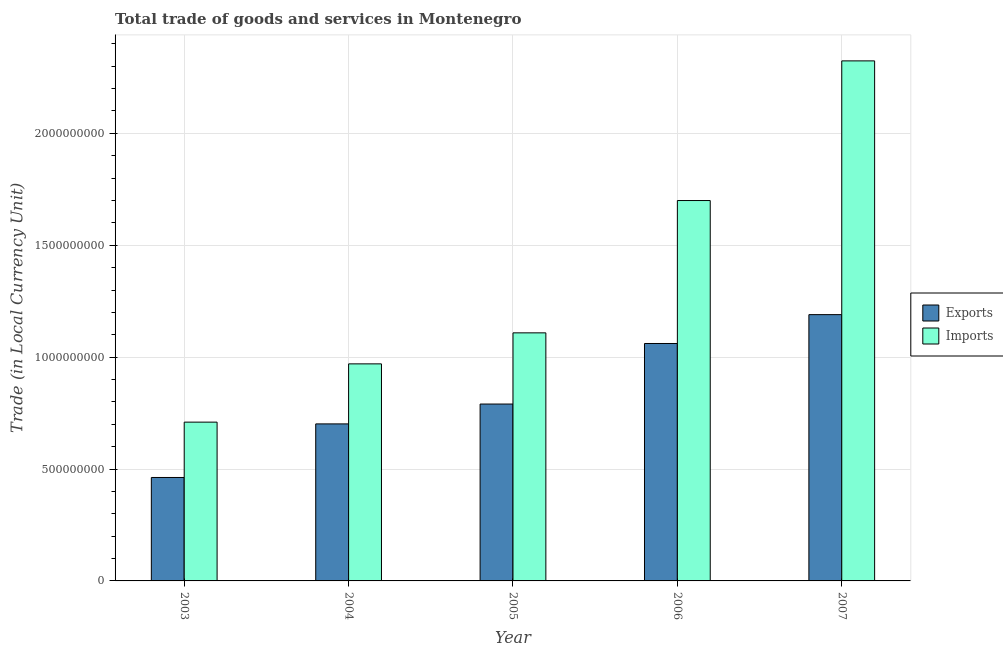Are the number of bars per tick equal to the number of legend labels?
Offer a terse response. Yes. Are the number of bars on each tick of the X-axis equal?
Give a very brief answer. Yes. How many bars are there on the 2nd tick from the left?
Your response must be concise. 2. How many bars are there on the 1st tick from the right?
Ensure brevity in your answer.  2. In how many cases, is the number of bars for a given year not equal to the number of legend labels?
Make the answer very short. 0. What is the imports of goods and services in 2005?
Give a very brief answer. 1.11e+09. Across all years, what is the maximum export of goods and services?
Your answer should be very brief. 1.19e+09. Across all years, what is the minimum imports of goods and services?
Your response must be concise. 7.10e+08. In which year was the imports of goods and services maximum?
Offer a very short reply. 2007. What is the total imports of goods and services in the graph?
Your answer should be very brief. 6.81e+09. What is the difference between the imports of goods and services in 2004 and that in 2006?
Make the answer very short. -7.30e+08. What is the difference between the export of goods and services in 2006 and the imports of goods and services in 2003?
Offer a terse response. 5.99e+08. What is the average imports of goods and services per year?
Offer a terse response. 1.36e+09. In the year 2003, what is the difference between the export of goods and services and imports of goods and services?
Ensure brevity in your answer.  0. What is the ratio of the export of goods and services in 2003 to that in 2004?
Offer a terse response. 0.66. Is the difference between the imports of goods and services in 2003 and 2007 greater than the difference between the export of goods and services in 2003 and 2007?
Your response must be concise. No. What is the difference between the highest and the second highest export of goods and services?
Give a very brief answer. 1.29e+08. What is the difference between the highest and the lowest imports of goods and services?
Keep it short and to the point. 1.61e+09. In how many years, is the imports of goods and services greater than the average imports of goods and services taken over all years?
Offer a very short reply. 2. Is the sum of the imports of goods and services in 2003 and 2005 greater than the maximum export of goods and services across all years?
Your answer should be compact. No. What does the 1st bar from the left in 2003 represents?
Your answer should be very brief. Exports. What does the 1st bar from the right in 2003 represents?
Provide a short and direct response. Imports. How many bars are there?
Your response must be concise. 10. Are all the bars in the graph horizontal?
Your answer should be compact. No. What is the difference between two consecutive major ticks on the Y-axis?
Offer a terse response. 5.00e+08. Does the graph contain any zero values?
Your answer should be compact. No. Does the graph contain grids?
Provide a succinct answer. Yes. How are the legend labels stacked?
Ensure brevity in your answer.  Vertical. What is the title of the graph?
Provide a short and direct response. Total trade of goods and services in Montenegro. Does "Primary" appear as one of the legend labels in the graph?
Offer a very short reply. No. What is the label or title of the X-axis?
Provide a short and direct response. Year. What is the label or title of the Y-axis?
Offer a very short reply. Trade (in Local Currency Unit). What is the Trade (in Local Currency Unit) in Exports in 2003?
Ensure brevity in your answer.  4.62e+08. What is the Trade (in Local Currency Unit) in Imports in 2003?
Give a very brief answer. 7.10e+08. What is the Trade (in Local Currency Unit) of Exports in 2004?
Give a very brief answer. 7.02e+08. What is the Trade (in Local Currency Unit) of Imports in 2004?
Make the answer very short. 9.70e+08. What is the Trade (in Local Currency Unit) of Exports in 2005?
Offer a terse response. 7.90e+08. What is the Trade (in Local Currency Unit) of Imports in 2005?
Provide a succinct answer. 1.11e+09. What is the Trade (in Local Currency Unit) of Exports in 2006?
Keep it short and to the point. 1.06e+09. What is the Trade (in Local Currency Unit) of Imports in 2006?
Give a very brief answer. 1.70e+09. What is the Trade (in Local Currency Unit) in Exports in 2007?
Offer a very short reply. 1.19e+09. What is the Trade (in Local Currency Unit) of Imports in 2007?
Offer a terse response. 2.32e+09. Across all years, what is the maximum Trade (in Local Currency Unit) in Exports?
Your response must be concise. 1.19e+09. Across all years, what is the maximum Trade (in Local Currency Unit) of Imports?
Ensure brevity in your answer.  2.32e+09. Across all years, what is the minimum Trade (in Local Currency Unit) in Exports?
Offer a very short reply. 4.62e+08. Across all years, what is the minimum Trade (in Local Currency Unit) of Imports?
Provide a succinct answer. 7.10e+08. What is the total Trade (in Local Currency Unit) in Exports in the graph?
Provide a short and direct response. 4.21e+09. What is the total Trade (in Local Currency Unit) in Imports in the graph?
Ensure brevity in your answer.  6.81e+09. What is the difference between the Trade (in Local Currency Unit) in Exports in 2003 and that in 2004?
Ensure brevity in your answer.  -2.39e+08. What is the difference between the Trade (in Local Currency Unit) in Imports in 2003 and that in 2004?
Provide a short and direct response. -2.60e+08. What is the difference between the Trade (in Local Currency Unit) in Exports in 2003 and that in 2005?
Keep it short and to the point. -3.28e+08. What is the difference between the Trade (in Local Currency Unit) in Imports in 2003 and that in 2005?
Your response must be concise. -3.99e+08. What is the difference between the Trade (in Local Currency Unit) in Exports in 2003 and that in 2006?
Your answer should be compact. -5.99e+08. What is the difference between the Trade (in Local Currency Unit) of Imports in 2003 and that in 2006?
Keep it short and to the point. -9.90e+08. What is the difference between the Trade (in Local Currency Unit) of Exports in 2003 and that in 2007?
Provide a short and direct response. -7.28e+08. What is the difference between the Trade (in Local Currency Unit) in Imports in 2003 and that in 2007?
Offer a very short reply. -1.61e+09. What is the difference between the Trade (in Local Currency Unit) of Exports in 2004 and that in 2005?
Your response must be concise. -8.87e+07. What is the difference between the Trade (in Local Currency Unit) of Imports in 2004 and that in 2005?
Your response must be concise. -1.39e+08. What is the difference between the Trade (in Local Currency Unit) of Exports in 2004 and that in 2006?
Offer a terse response. -3.59e+08. What is the difference between the Trade (in Local Currency Unit) in Imports in 2004 and that in 2006?
Make the answer very short. -7.30e+08. What is the difference between the Trade (in Local Currency Unit) of Exports in 2004 and that in 2007?
Provide a succinct answer. -4.88e+08. What is the difference between the Trade (in Local Currency Unit) in Imports in 2004 and that in 2007?
Provide a short and direct response. -1.35e+09. What is the difference between the Trade (in Local Currency Unit) of Exports in 2005 and that in 2006?
Your answer should be compact. -2.71e+08. What is the difference between the Trade (in Local Currency Unit) in Imports in 2005 and that in 2006?
Your response must be concise. -5.91e+08. What is the difference between the Trade (in Local Currency Unit) of Exports in 2005 and that in 2007?
Give a very brief answer. -4.00e+08. What is the difference between the Trade (in Local Currency Unit) of Imports in 2005 and that in 2007?
Offer a very short reply. -1.22e+09. What is the difference between the Trade (in Local Currency Unit) in Exports in 2006 and that in 2007?
Your response must be concise. -1.29e+08. What is the difference between the Trade (in Local Currency Unit) of Imports in 2006 and that in 2007?
Your answer should be very brief. -6.24e+08. What is the difference between the Trade (in Local Currency Unit) of Exports in 2003 and the Trade (in Local Currency Unit) of Imports in 2004?
Offer a terse response. -5.08e+08. What is the difference between the Trade (in Local Currency Unit) of Exports in 2003 and the Trade (in Local Currency Unit) of Imports in 2005?
Your answer should be very brief. -6.46e+08. What is the difference between the Trade (in Local Currency Unit) of Exports in 2003 and the Trade (in Local Currency Unit) of Imports in 2006?
Offer a very short reply. -1.24e+09. What is the difference between the Trade (in Local Currency Unit) in Exports in 2003 and the Trade (in Local Currency Unit) in Imports in 2007?
Keep it short and to the point. -1.86e+09. What is the difference between the Trade (in Local Currency Unit) of Exports in 2004 and the Trade (in Local Currency Unit) of Imports in 2005?
Offer a very short reply. -4.07e+08. What is the difference between the Trade (in Local Currency Unit) of Exports in 2004 and the Trade (in Local Currency Unit) of Imports in 2006?
Your answer should be compact. -9.98e+08. What is the difference between the Trade (in Local Currency Unit) of Exports in 2004 and the Trade (in Local Currency Unit) of Imports in 2007?
Ensure brevity in your answer.  -1.62e+09. What is the difference between the Trade (in Local Currency Unit) of Exports in 2005 and the Trade (in Local Currency Unit) of Imports in 2006?
Keep it short and to the point. -9.09e+08. What is the difference between the Trade (in Local Currency Unit) in Exports in 2005 and the Trade (in Local Currency Unit) in Imports in 2007?
Ensure brevity in your answer.  -1.53e+09. What is the difference between the Trade (in Local Currency Unit) of Exports in 2006 and the Trade (in Local Currency Unit) of Imports in 2007?
Offer a terse response. -1.26e+09. What is the average Trade (in Local Currency Unit) of Exports per year?
Your response must be concise. 8.41e+08. What is the average Trade (in Local Currency Unit) in Imports per year?
Offer a terse response. 1.36e+09. In the year 2003, what is the difference between the Trade (in Local Currency Unit) of Exports and Trade (in Local Currency Unit) of Imports?
Offer a very short reply. -2.47e+08. In the year 2004, what is the difference between the Trade (in Local Currency Unit) in Exports and Trade (in Local Currency Unit) in Imports?
Give a very brief answer. -2.68e+08. In the year 2005, what is the difference between the Trade (in Local Currency Unit) in Exports and Trade (in Local Currency Unit) in Imports?
Ensure brevity in your answer.  -3.18e+08. In the year 2006, what is the difference between the Trade (in Local Currency Unit) of Exports and Trade (in Local Currency Unit) of Imports?
Your response must be concise. -6.39e+08. In the year 2007, what is the difference between the Trade (in Local Currency Unit) in Exports and Trade (in Local Currency Unit) in Imports?
Ensure brevity in your answer.  -1.13e+09. What is the ratio of the Trade (in Local Currency Unit) in Exports in 2003 to that in 2004?
Offer a terse response. 0.66. What is the ratio of the Trade (in Local Currency Unit) of Imports in 2003 to that in 2004?
Your response must be concise. 0.73. What is the ratio of the Trade (in Local Currency Unit) of Exports in 2003 to that in 2005?
Give a very brief answer. 0.58. What is the ratio of the Trade (in Local Currency Unit) of Imports in 2003 to that in 2005?
Your answer should be compact. 0.64. What is the ratio of the Trade (in Local Currency Unit) in Exports in 2003 to that in 2006?
Your response must be concise. 0.44. What is the ratio of the Trade (in Local Currency Unit) in Imports in 2003 to that in 2006?
Provide a short and direct response. 0.42. What is the ratio of the Trade (in Local Currency Unit) in Exports in 2003 to that in 2007?
Provide a short and direct response. 0.39. What is the ratio of the Trade (in Local Currency Unit) of Imports in 2003 to that in 2007?
Offer a terse response. 0.31. What is the ratio of the Trade (in Local Currency Unit) of Exports in 2004 to that in 2005?
Provide a succinct answer. 0.89. What is the ratio of the Trade (in Local Currency Unit) in Imports in 2004 to that in 2005?
Your answer should be compact. 0.88. What is the ratio of the Trade (in Local Currency Unit) in Exports in 2004 to that in 2006?
Give a very brief answer. 0.66. What is the ratio of the Trade (in Local Currency Unit) of Imports in 2004 to that in 2006?
Offer a terse response. 0.57. What is the ratio of the Trade (in Local Currency Unit) of Exports in 2004 to that in 2007?
Make the answer very short. 0.59. What is the ratio of the Trade (in Local Currency Unit) in Imports in 2004 to that in 2007?
Your response must be concise. 0.42. What is the ratio of the Trade (in Local Currency Unit) of Exports in 2005 to that in 2006?
Make the answer very short. 0.74. What is the ratio of the Trade (in Local Currency Unit) in Imports in 2005 to that in 2006?
Your answer should be compact. 0.65. What is the ratio of the Trade (in Local Currency Unit) in Exports in 2005 to that in 2007?
Provide a succinct answer. 0.66. What is the ratio of the Trade (in Local Currency Unit) in Imports in 2005 to that in 2007?
Offer a very short reply. 0.48. What is the ratio of the Trade (in Local Currency Unit) in Exports in 2006 to that in 2007?
Your answer should be compact. 0.89. What is the ratio of the Trade (in Local Currency Unit) in Imports in 2006 to that in 2007?
Your answer should be very brief. 0.73. What is the difference between the highest and the second highest Trade (in Local Currency Unit) of Exports?
Make the answer very short. 1.29e+08. What is the difference between the highest and the second highest Trade (in Local Currency Unit) of Imports?
Give a very brief answer. 6.24e+08. What is the difference between the highest and the lowest Trade (in Local Currency Unit) of Exports?
Your answer should be very brief. 7.28e+08. What is the difference between the highest and the lowest Trade (in Local Currency Unit) of Imports?
Offer a terse response. 1.61e+09. 